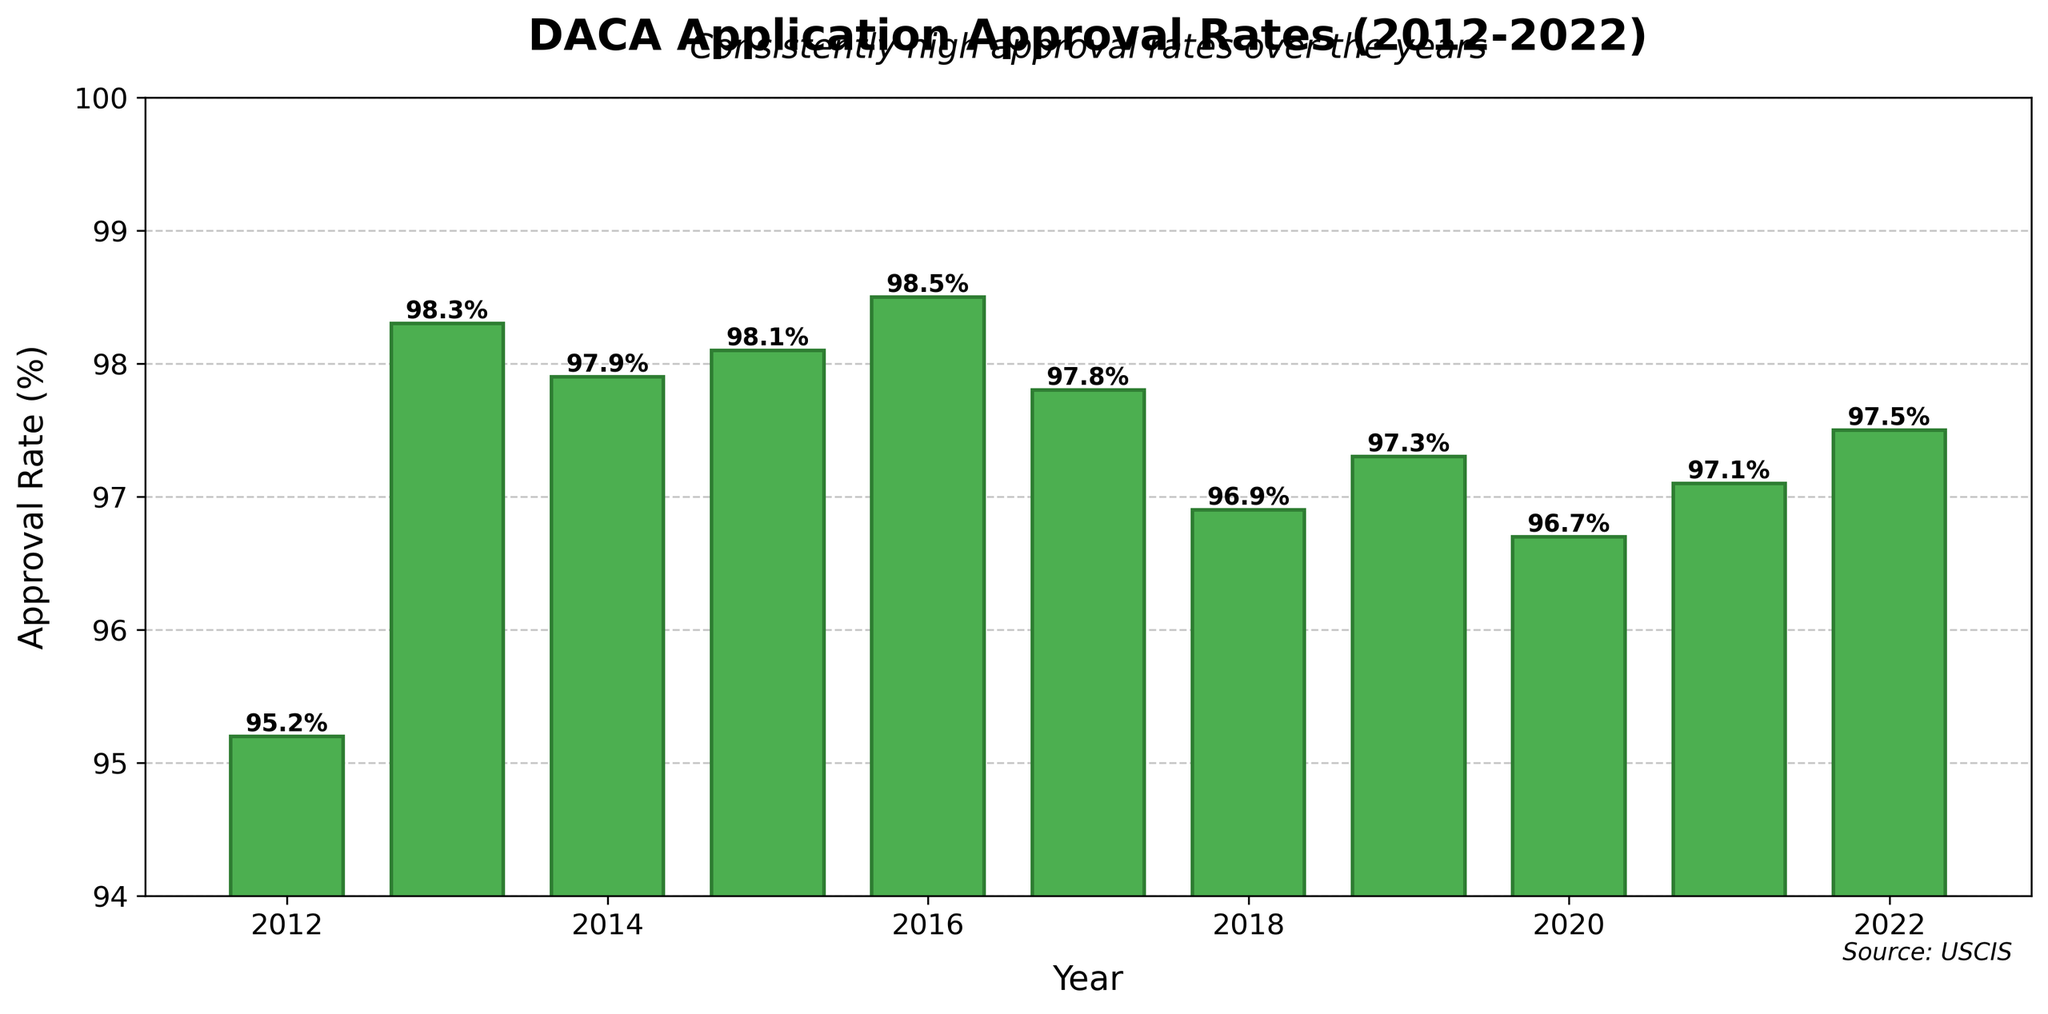What year had the highest DACA application approval rate? To find the highest approval rate, look for the tallest bar in the chart or the label with the highest percentage. In this case, the year with the highest approval rate is 2016 with an approval rate of 98.5%.
Answer: 2016 Which year had a lower approval rate, 2012 or 2017? To determine which year had the lower approval rate between 2012 and 2017, compare the heights of the bars or the percentages directly. 2012 had an approval rate of 95.2%, and 2017 had an approval rate of 97.8%. Hence, 2012 had a lower approval rate.
Answer: 2012 What is the average DACA application approval rate from 2015 to 2020? Calculate the average approval rate for the years from 2015 to 2020 by adding the approval rates for each year (98.1, 98.5, 97.8, 96.9, 97.3, 96.7) and then dividing by the number of those years (6). The sum of the approval rates is 585.3, and dividing this by 6 gives approximately 97.6%.
Answer: 97.6% In which year did the DACA application approval rate decrease the most compared to the previous year? To find the year with the most significant decrease, we need to find the differences in approval rates from one year to the next and identify the largest negative difference. The most significant decrease is from 2016 (98.5%) to 2017 (97.8%), which is a decrease of 0.7%.
Answer: 2017 How many years had approval rates below 97%? To determine the number of years with approval rates below 97%, identify the bars or labels with percentages less than 97%. The years are 2012 (95.2%), 2018 (96.9%), and 2020 (96.7%). Therefore, there are 3 years.
Answer: 3 Between which two consecutive years was the approval rate change the smallest? To find the smallest change between consecutive years, calculate the absolute differences between the approval rates of consecutive years and compare them. The differences are, in order: 3.1, 0.4, 0.2, 0.4, 0.7, -0.9, 0.4, -0.6, 0.4, 0.4. The smallest change is between 2019 (97.3%) and 2020 (96.7%), a difference of 0.2%.
Answer: 2019 and 2020 